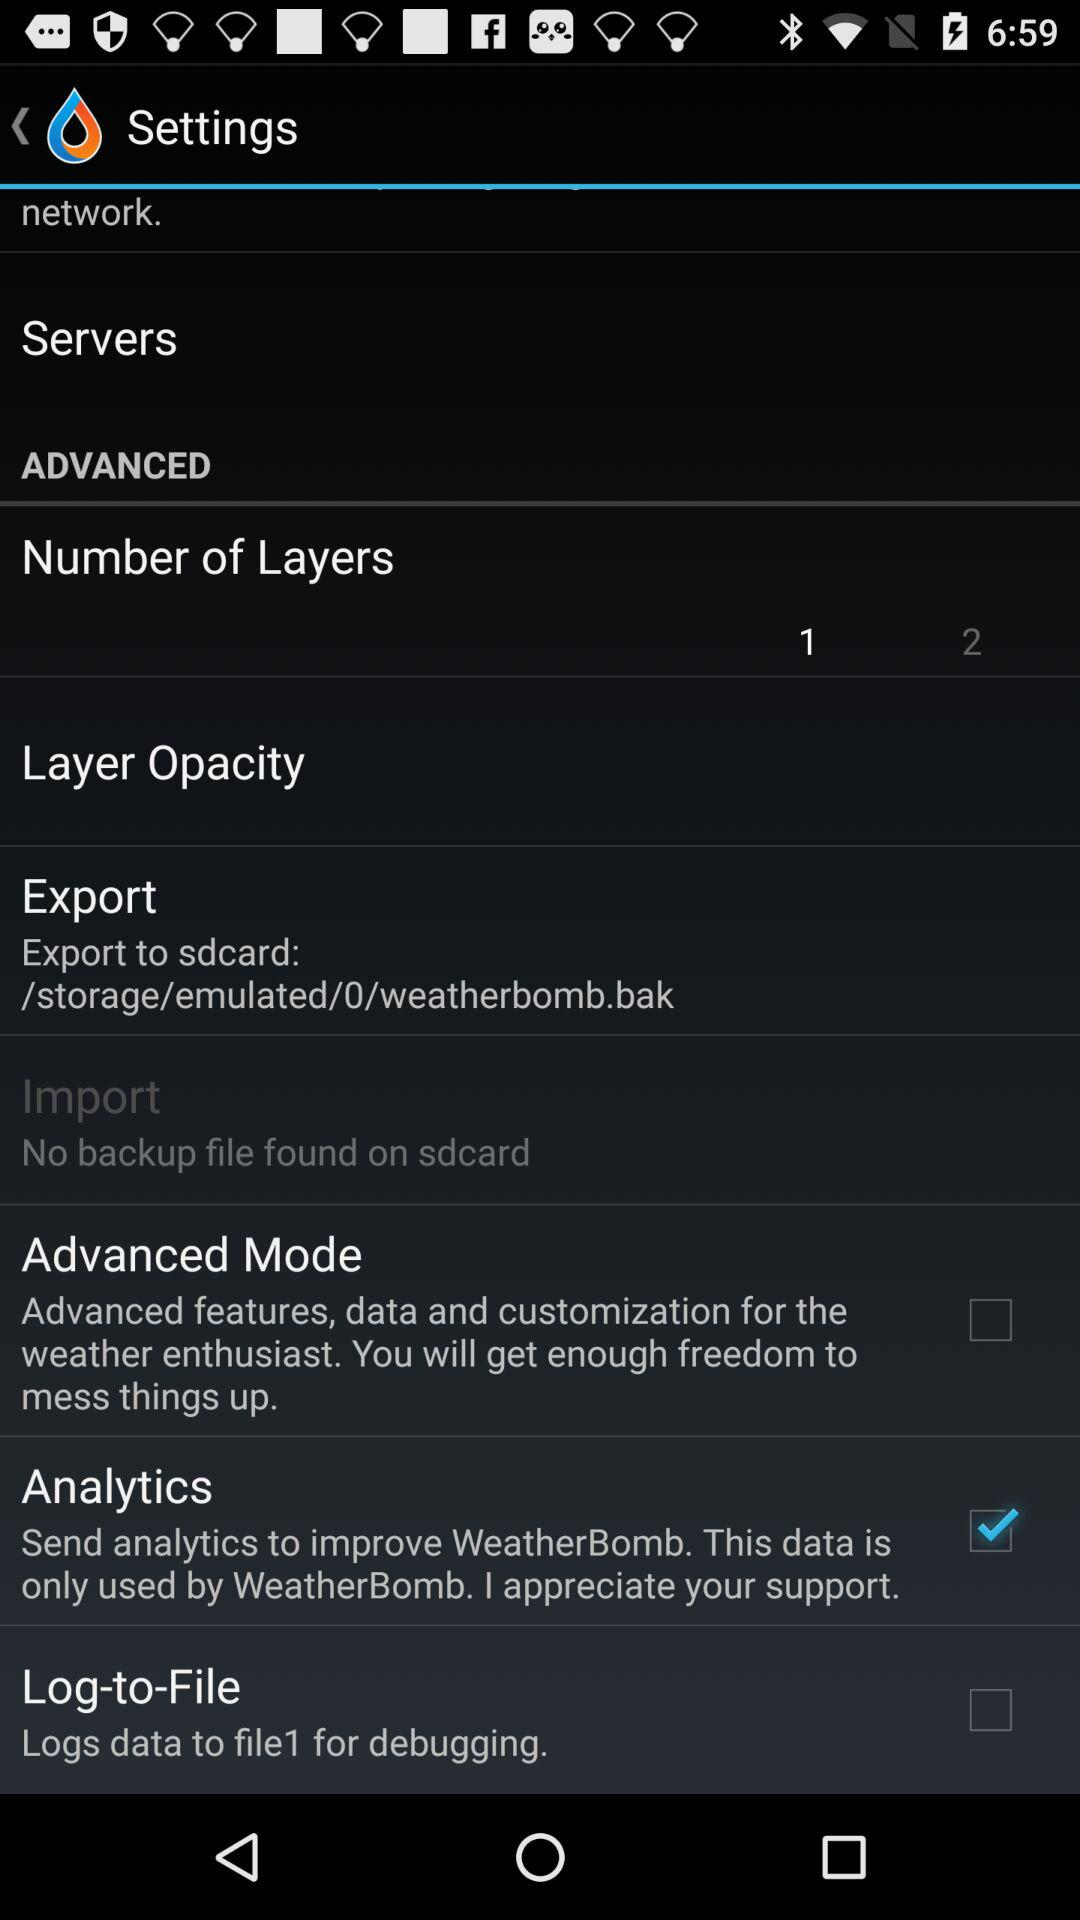How many of the items have a checkbox?
Answer the question using a single word or phrase. 3 